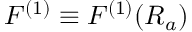Convert formula to latex. <formula><loc_0><loc_0><loc_500><loc_500>F ^ { ( 1 ) } \equiv F ^ { ( 1 ) } ( R _ { a } )</formula> 